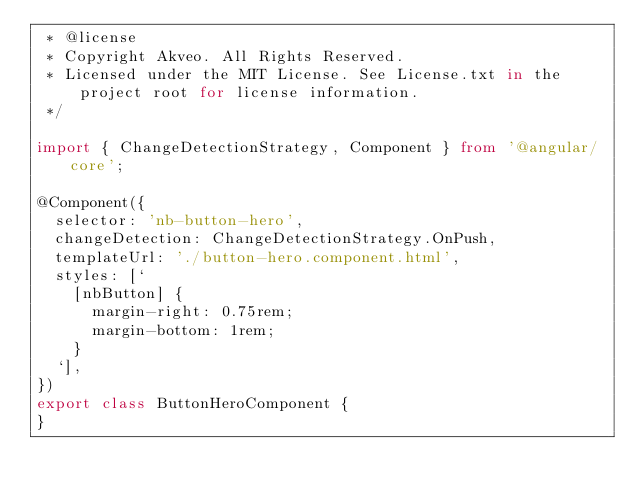<code> <loc_0><loc_0><loc_500><loc_500><_TypeScript_> * @license
 * Copyright Akveo. All Rights Reserved.
 * Licensed under the MIT License. See License.txt in the project root for license information.
 */

import { ChangeDetectionStrategy, Component } from '@angular/core';

@Component({
  selector: 'nb-button-hero',
  changeDetection: ChangeDetectionStrategy.OnPush,
  templateUrl: './button-hero.component.html',
  styles: [`
    [nbButton] {
      margin-right: 0.75rem;
      margin-bottom: 1rem;
    }
  `],
})
export class ButtonHeroComponent {
}
</code> 